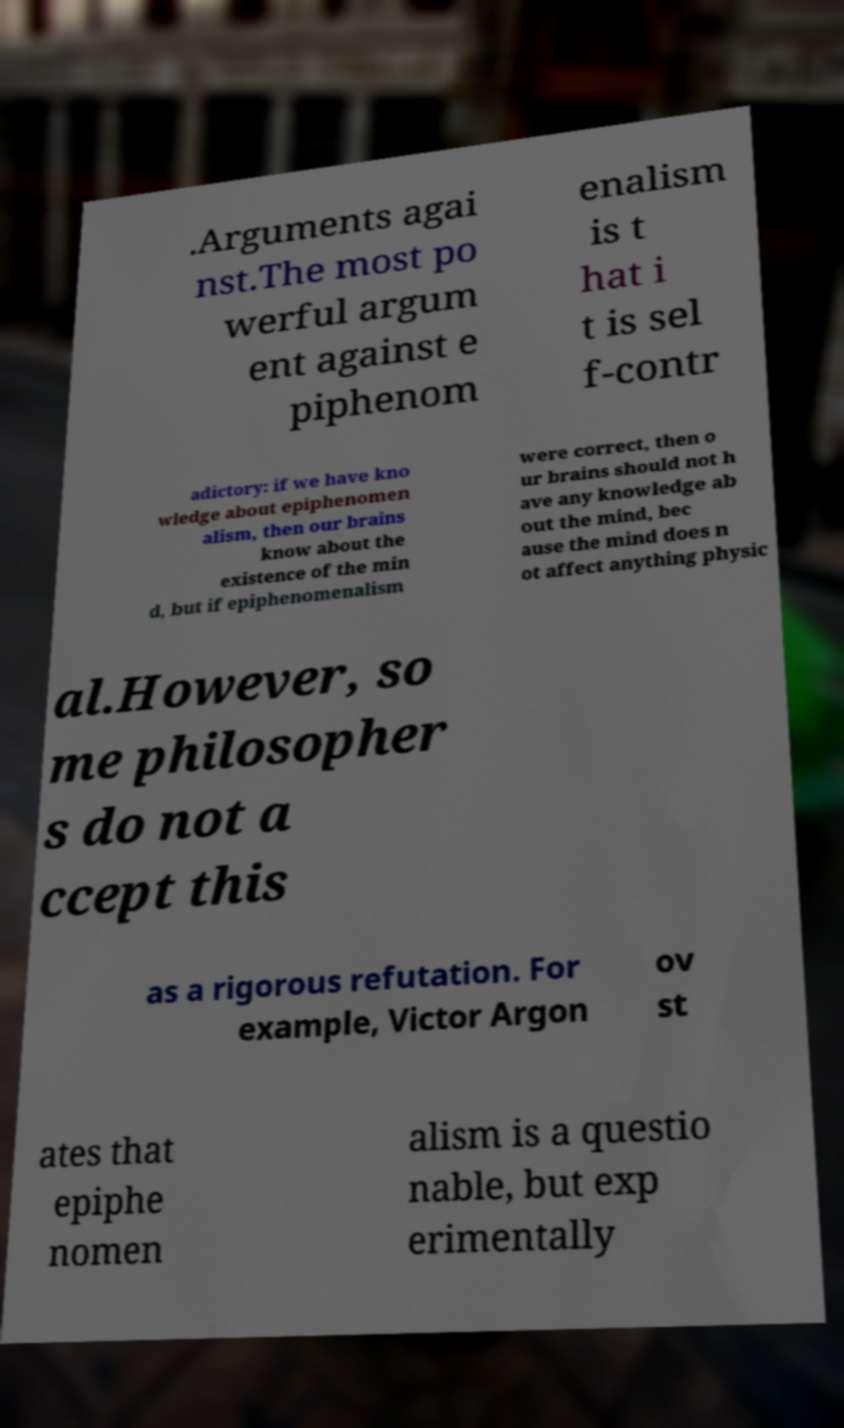Can you accurately transcribe the text from the provided image for me? .Arguments agai nst.The most po werful argum ent against e piphenom enalism is t hat i t is sel f-contr adictory: if we have kno wledge about epiphenomen alism, then our brains know about the existence of the min d, but if epiphenomenalism were correct, then o ur brains should not h ave any knowledge ab out the mind, bec ause the mind does n ot affect anything physic al.However, so me philosopher s do not a ccept this as a rigorous refutation. For example, Victor Argon ov st ates that epiphe nomen alism is a questio nable, but exp erimentally 